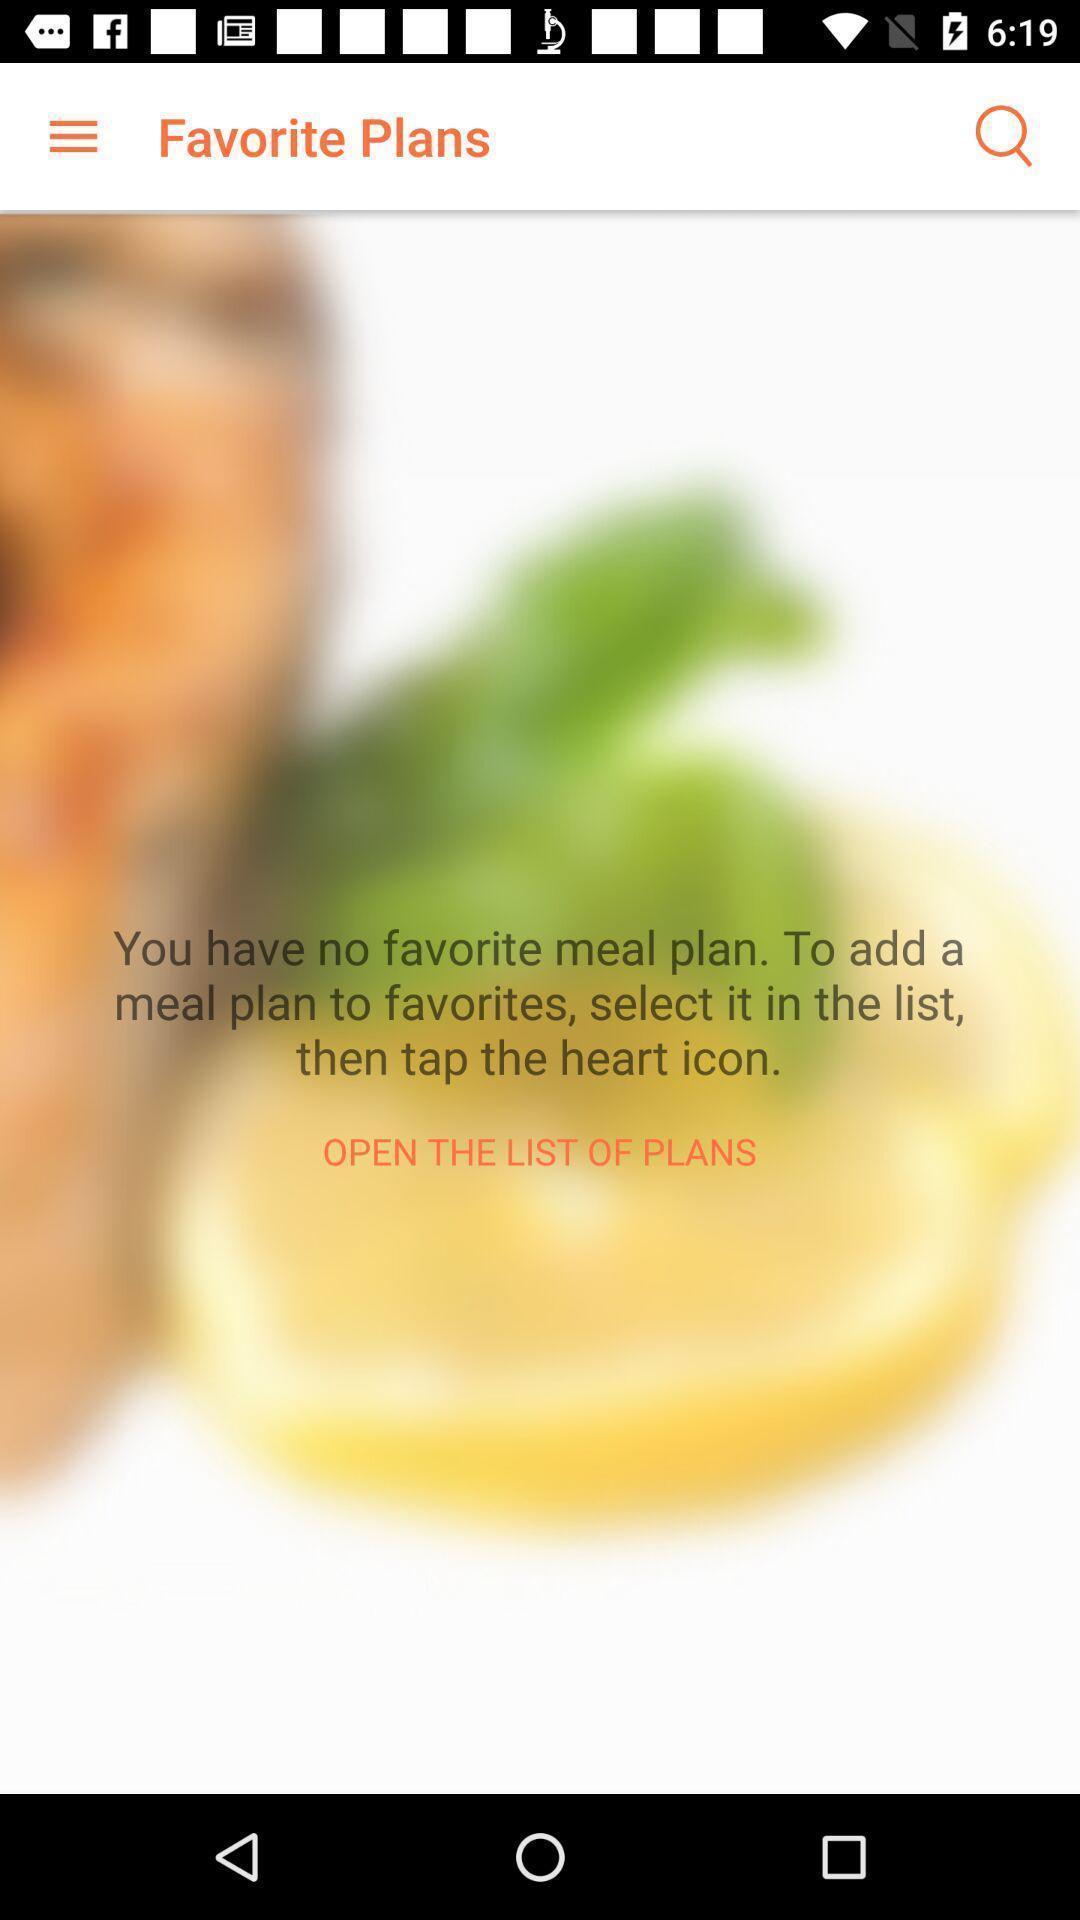Explain what's happening in this screen capture. Page displaying to open list of plans. 